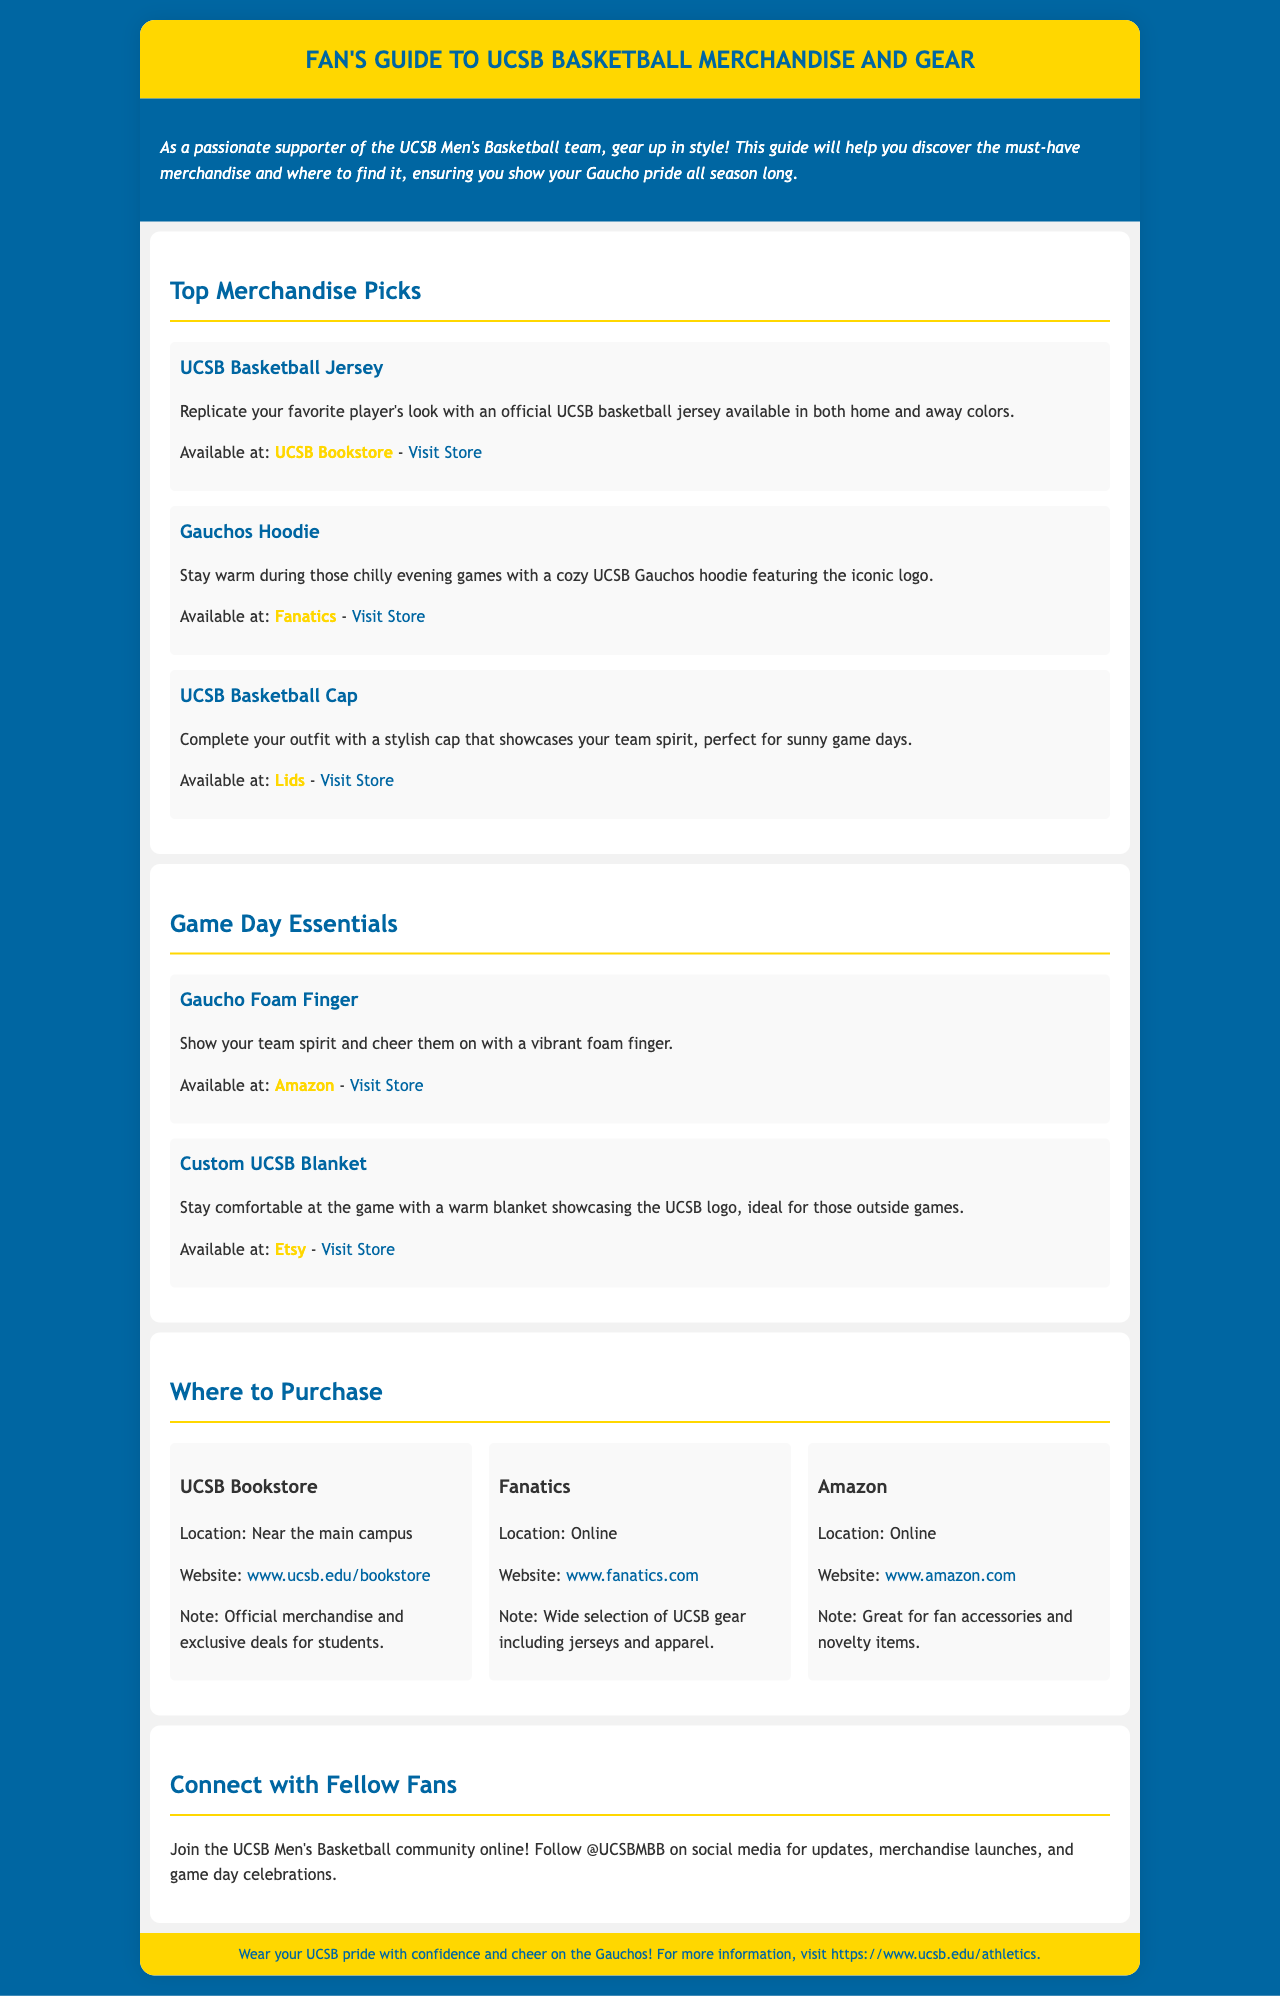What merchandise can I get to replicate my favorite player's look? The document lists the UCSB Basketball Jersey as merchandise to replicate a favorite player's look.
Answer: UCSB Basketball Jersey Where can I find the Gauchos Hoodie? The Gauchos Hoodie is available at Fanatics.
Answer: Fanatics What is the color of the background for the brochure? The background color of the brochure is specified as #0066A2.
Answer: #0066A2 What item can keep me comfortable during outside games? The document mentions a custom UCSB Blanket as an item to stay comfortable during outside games.
Answer: Custom UCSB Blanket How can I connect with fellow fans? The document suggests following @UCSBMBB on social media to connect with fellow fans.
Answer: @UCSBMBB What do you find at the UCSB Bookstore? According to the document, you can find official merchandise at the UCSB Bookstore.
Answer: Official merchandise Where is the UCSB Bookstore located? The document states that the UCSB Bookstore is located near the main campus.
Answer: Near the main campus What type of products does Amazon offer for fans? The document mentions that Amazon offers fan accessories and novelty items.
Answer: Fan accessories and novelty items What color is the Gauchos Hoodie? The document does not specify the exact color but indicates it features the iconic logo.
Answer: Iconic logo 